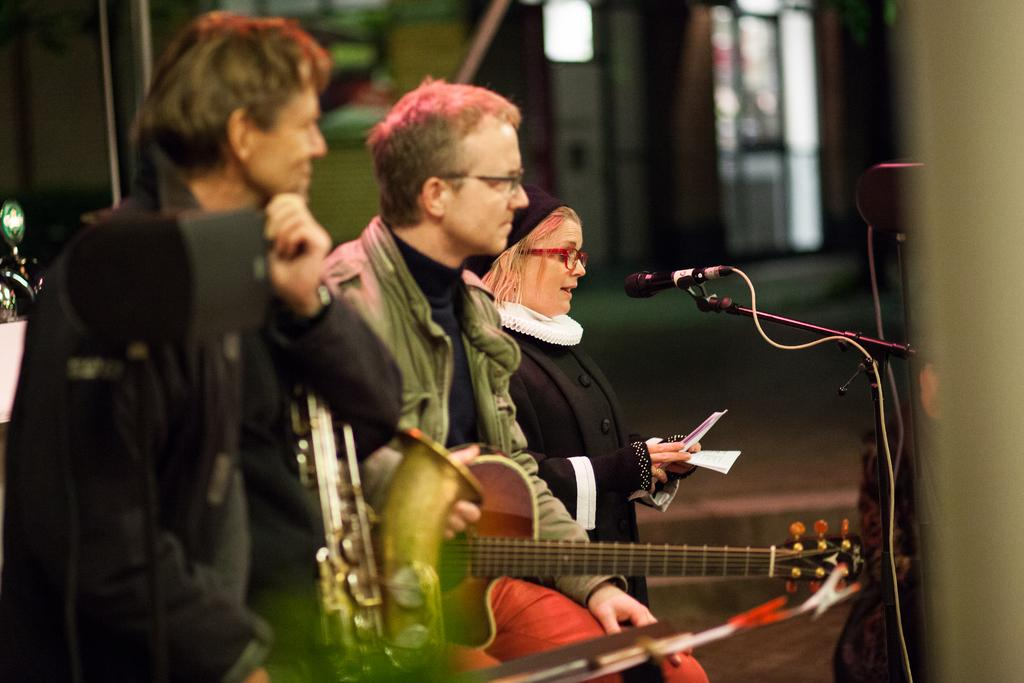How many people are in the image? There are two men and one woman in the image. What is one of the men doing in the image? One man is playing a guitar. What is the woman doing in the image? The woman is singing into a microphone. Where is the microphone positioned in relation to the man playing the guitar? The microphone is in front of the man playing the guitar. What type of pen is the man using to write a song in the image? There is no pen or writing activity present in the image. What type of brass instrument is the woman playing in the image? The woman is not playing a brass instrument in the image; she is singing into a microphone. 